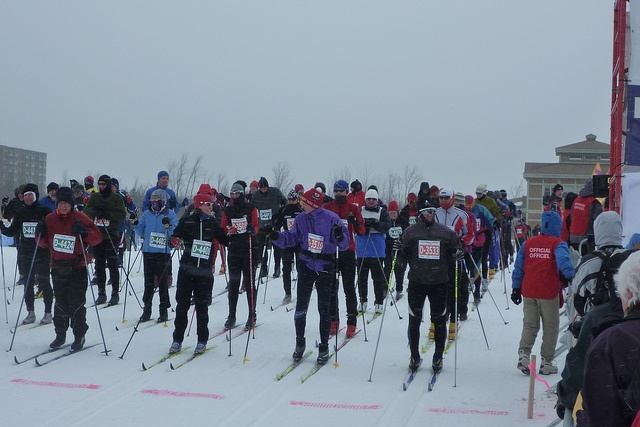Describe the objects in this image and their specific colors. I can see people in darkgray, black, gray, and navy tones, people in darkgray, black, and gray tones, people in darkgray, black, and gray tones, people in darkgray, black, and gray tones, and people in darkgray, black, navy, and gray tones in this image. 